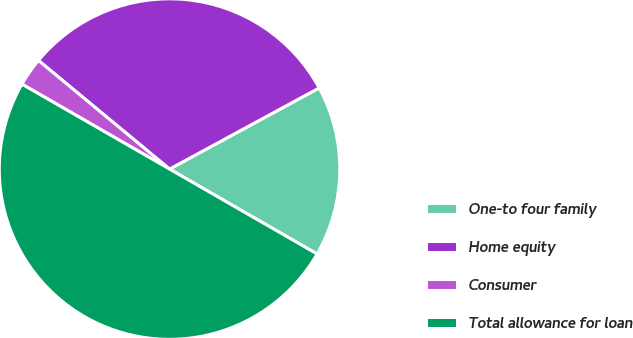Convert chart to OTSL. <chart><loc_0><loc_0><loc_500><loc_500><pie_chart><fcel>One-to four family<fcel>Home equity<fcel>Consumer<fcel>Total allowance for loan<nl><fcel>16.22%<fcel>31.08%<fcel>2.7%<fcel>50.0%<nl></chart> 